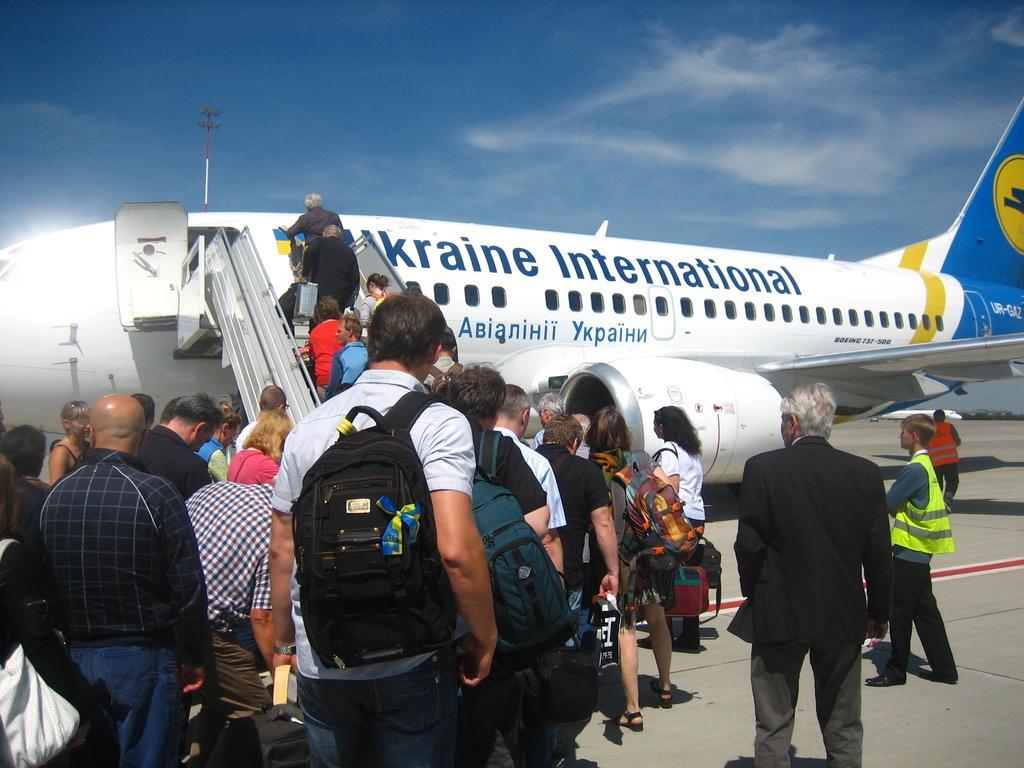How would you summarize this image in a sentence or two? In this image I see number of people and I see the steps over here on which there are few more people and I see an aeroplane over here which is of white, blue and yellow in color and I see few words written on it and I see the path. In the background I see the sky, a pole over here and I see another aeroplane over here. 